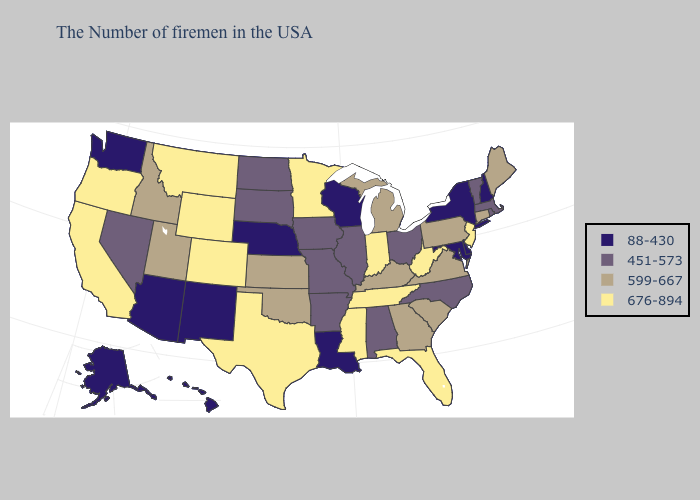What is the value of New Hampshire?
Concise answer only. 88-430. Among the states that border Arizona , which have the lowest value?
Keep it brief. New Mexico. Name the states that have a value in the range 676-894?
Keep it brief. New Jersey, West Virginia, Florida, Indiana, Tennessee, Mississippi, Minnesota, Texas, Wyoming, Colorado, Montana, California, Oregon. Among the states that border Indiana , does Michigan have the highest value?
Quick response, please. Yes. What is the value of Michigan?
Keep it brief. 599-667. Does Hawaii have the highest value in the USA?
Give a very brief answer. No. Name the states that have a value in the range 599-667?
Quick response, please. Maine, Connecticut, Pennsylvania, Virginia, South Carolina, Georgia, Michigan, Kentucky, Kansas, Oklahoma, Utah, Idaho. What is the value of Delaware?
Write a very short answer. 88-430. Among the states that border Oregon , which have the lowest value?
Short answer required. Washington. How many symbols are there in the legend?
Quick response, please. 4. How many symbols are there in the legend?
Concise answer only. 4. Which states have the lowest value in the MidWest?
Give a very brief answer. Wisconsin, Nebraska. What is the value of Tennessee?
Concise answer only. 676-894. Which states hav the highest value in the MidWest?
Be succinct. Indiana, Minnesota. What is the value of Kansas?
Be succinct. 599-667. 